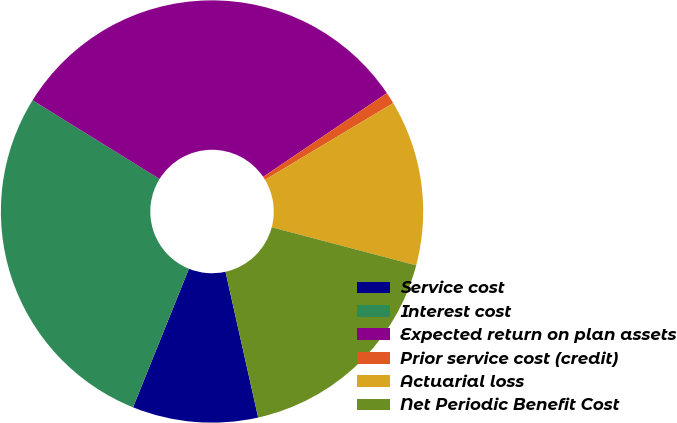Convert chart. <chart><loc_0><loc_0><loc_500><loc_500><pie_chart><fcel>Service cost<fcel>Interest cost<fcel>Expected return on plan assets<fcel>Prior service cost (credit)<fcel>Actuarial loss<fcel>Net Periodic Benefit Cost<nl><fcel>9.61%<fcel>27.73%<fcel>31.7%<fcel>0.89%<fcel>12.69%<fcel>17.39%<nl></chart> 